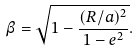Convert formula to latex. <formula><loc_0><loc_0><loc_500><loc_500>\beta = \sqrt { 1 - \frac { ( R / a ) ^ { 2 } } { 1 - e ^ { 2 } } } .</formula> 